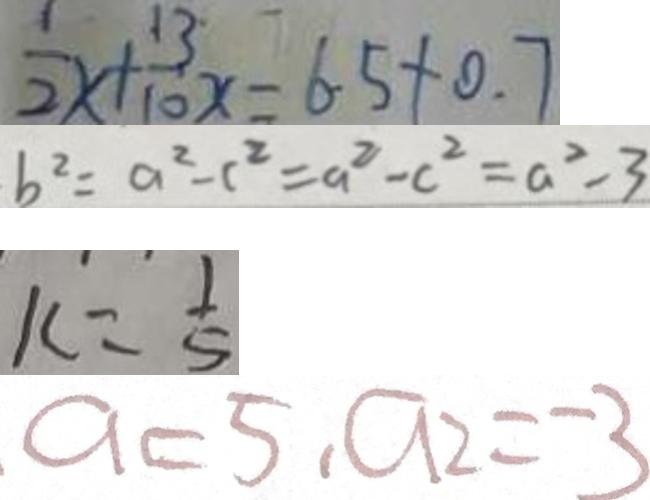<formula> <loc_0><loc_0><loc_500><loc_500>\frac { 1 } { 2 } x + \frac { 1 3 } { 1 0 } x = 6 . 5 + 0 . 7 
 b ^ { 2 } = a ^ { 2 } - c ^ { 2 } = a ^ { 2 } - c ^ { 2 } = a ^ { 2 } - 3 
 k = \frac { 1 } { 5 } 
 a = 5 , a _ { 2 } = - 3</formula> 